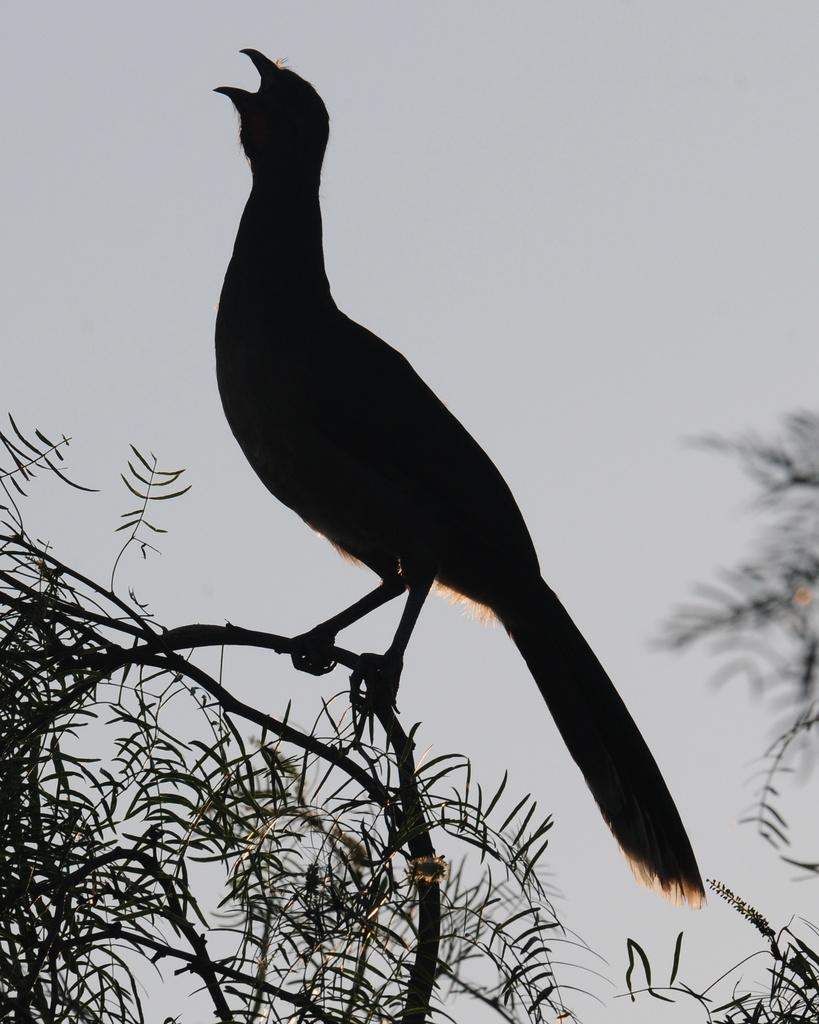What type of animal is in the image? There is a bird in the image. Where is the bird located? The bird is on a branch. What can be seen on both sides of the image? There are trees on the left side and the right side of the image. What is visible behind the bird? The sky is visible behind the bird. What is the price of the music playing in the background of the image? There is no music playing in the background of the image, and therefore no price can be determined. 